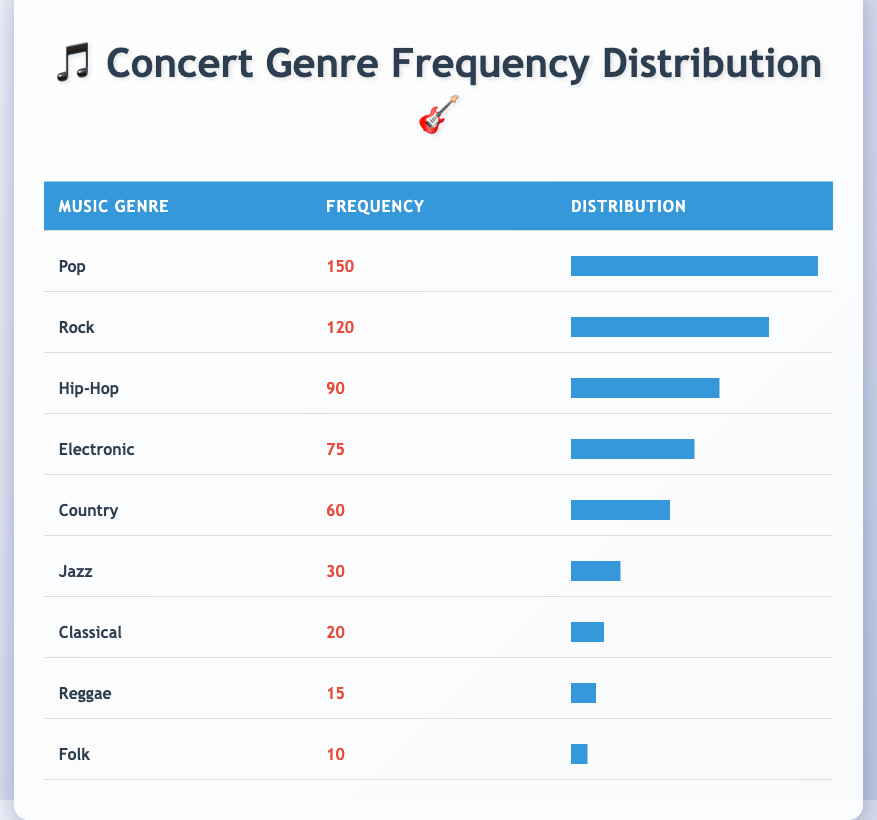What is the frequency of the Pop genre among concertgoers? The frequency of the Pop genre is listed directly in the table as 150.
Answer: 150 What genre has the second-highest frequency? The table shows that Rock has a frequency of 120, which is the second-highest after Pop.
Answer: Rock What is the total frequency of all music genres listed? To find the total frequency, sum the frequencies: 150 + 120 + 90 + 75 + 60 + 30 + 20 + 15 + 10 = 600.
Answer: 600 Is Jazz the least preferred music genre among concertgoers? The table shows Jazz has a frequency of 30, while Folk has a lower frequency of 10, indicating that Jazz is not the least preferred.
Answer: No What percent of concertgoers prefer Hip-Hop compared to Pop? Hip-Hop's frequency is 90 and Pop is 150. To find the percentage of Hip-Hop concerning Pop: (90/150) * 100 = 60%.
Answer: 60% Which genre has a frequency less than 50, and what is that frequency? The genres with frequencies less than 50 are Classical (20), Reggae (15), and Folk (10). The frequencies are 20, 15, and 10 respectively.
Answer: 20, 15, 10 What is the difference in frequency between the most and least preferred genres? The most preferred genre is Pop with a frequency of 150, and the least preferred is Folk with a frequency of 10. The difference is 150 - 10 = 140.
Answer: 140 Are there more concertgoers who prefer Rock than those who prefer Country? Rock has a frequency of 120 while Country has a frequency of 60, which shows that there are indeed more concertgoers who prefer Rock.
Answer: Yes What is the average frequency of the genres listed in the table? First, sum all the frequencies to get a total of 600. There are 9 genres, so the average frequency is 600 / 9 = 66.67.
Answer: 66.67 